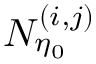<formula> <loc_0><loc_0><loc_500><loc_500>N _ { \eta _ { 0 } } ^ { ( i , j ) }</formula> 